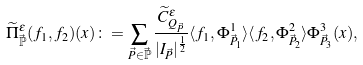Convert formula to latex. <formula><loc_0><loc_0><loc_500><loc_500>\widetilde { \Pi } ^ { \varepsilon } _ { \vec { \mathbb { P } } } ( f _ { 1 } , f _ { 2 } ) ( x ) \colon = \sum _ { \vec { P } \in \vec { \mathbb { P } } } \frac { \widetilde { C } ^ { \varepsilon } _ { Q _ { \vec { P } } } } { | I _ { \vec { P } } | ^ { \frac { 1 } { 2 } } } \langle f _ { 1 } , \Phi ^ { 1 } _ { \vec { P } _ { 1 } } \rangle \langle f _ { 2 } , \Phi ^ { 2 } _ { \vec { P } _ { 2 } } \rangle \Phi ^ { 3 } _ { \vec { P } _ { 3 } } ( x ) ,</formula> 